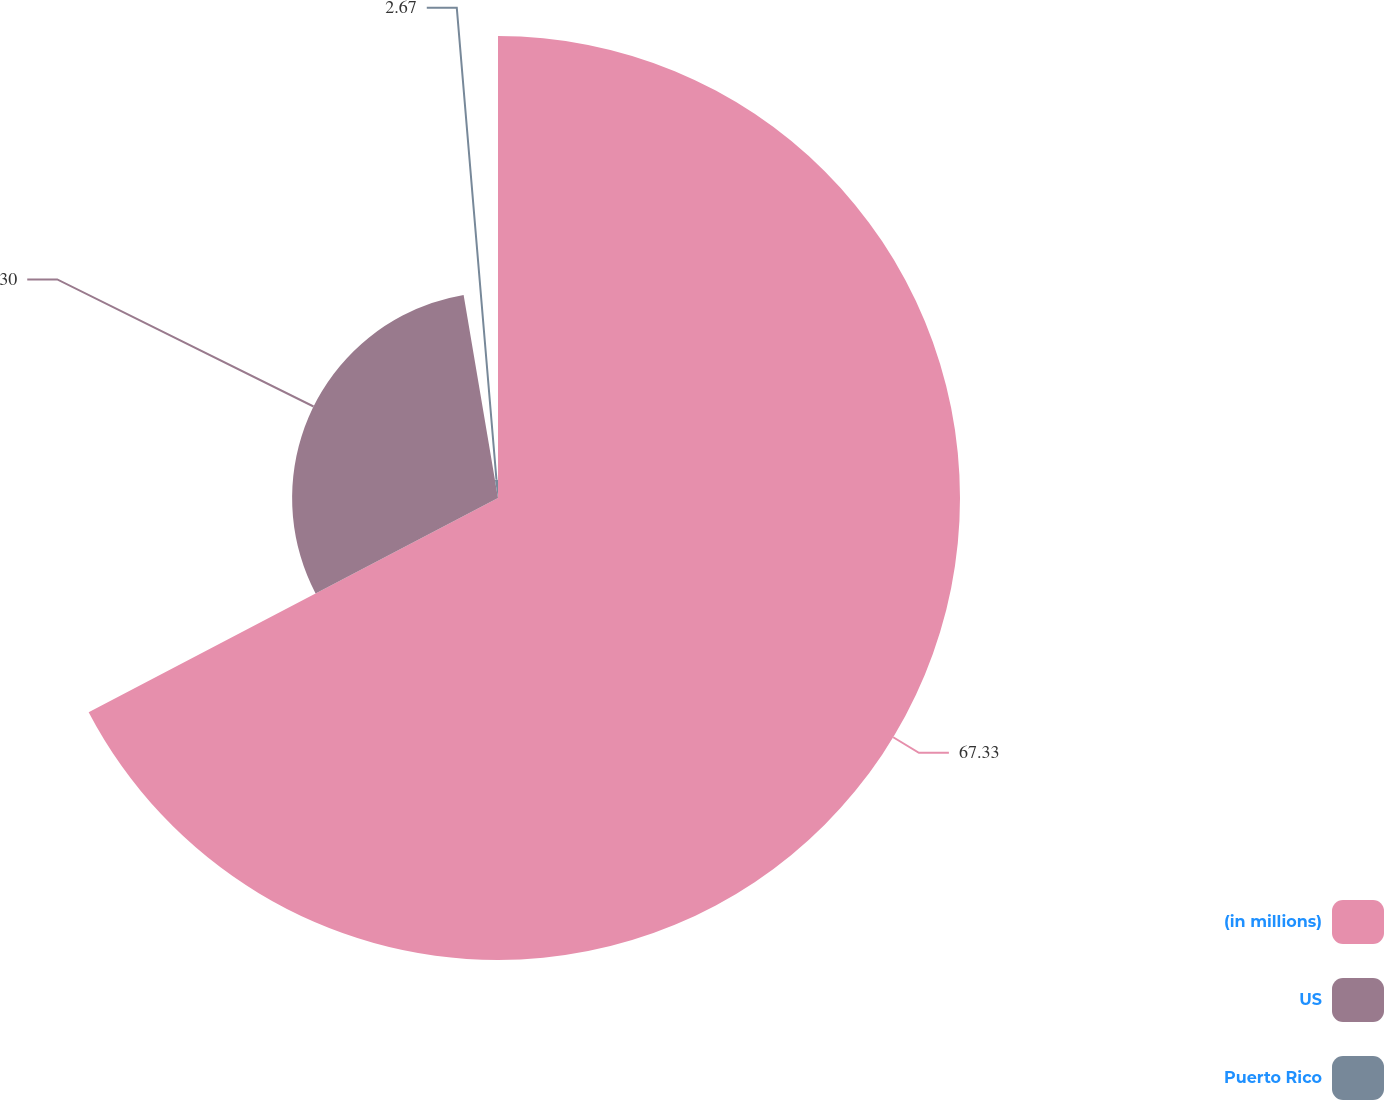Convert chart to OTSL. <chart><loc_0><loc_0><loc_500><loc_500><pie_chart><fcel>(in millions)<fcel>US<fcel>Puerto Rico<nl><fcel>67.32%<fcel>30.0%<fcel>2.67%<nl></chart> 